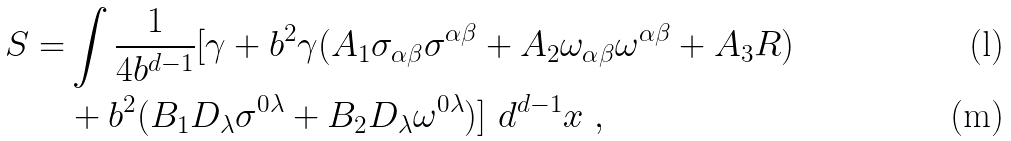Convert formula to latex. <formula><loc_0><loc_0><loc_500><loc_500>S = & \int \frac { 1 } { 4 b ^ { d - 1 } } [ \gamma + b ^ { 2 } \gamma ( A _ { 1 } \sigma _ { \alpha \beta } \sigma ^ { \alpha \beta } + A _ { 2 } \omega _ { \alpha \beta } \omega ^ { \alpha \beta } + A _ { 3 } R ) \\ & + b ^ { 2 } ( B _ { 1 } D _ { \lambda } \sigma ^ { 0 \lambda } + B _ { 2 } D _ { \lambda } \omega ^ { 0 \lambda } ) ] \ d ^ { d - 1 } x \ ,</formula> 